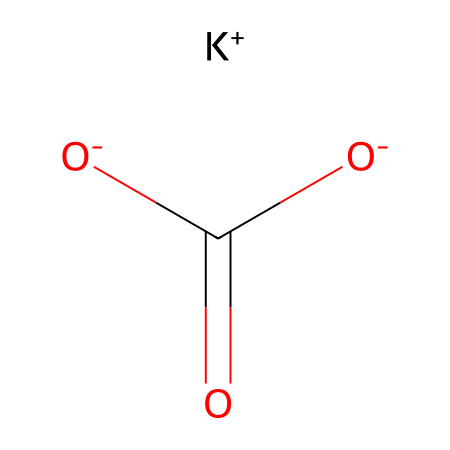What is the molecular formula of potassium bicarbonate? The SMILES representation breaks down to potassium (K), two oxygen atoms (O), and hydrogen (H) atoms in the bicarbonate ion (HCO3-). Therefore, the molecular formula is KHC(=O)2O2.
Answer: KHC(=O)2O2 How many oxygen atoms are in potassium bicarbonate? In the structure provided by the SMILES, there are three oxygen atoms indicated by the "[O-]" notation and the carbonyl "C(=O)", leading to a total of three.
Answer: 3 What is the charge of the potassium ion in this compound? The "[K+]" notation in the SMILES shows that the potassium ion has a positive charge, indicating it is a cation.
Answer: +1 What type of compound is potassium bicarbonate classified as? The chemical has a potassium cation and a bicarbonate anion, which lies within the category of salts, specifically electrolytes.
Answer: electrolyte Does potassium bicarbonate possess acidic properties? The presence of the bicarbonate anion (HCO3-) in the chemical structure gives potassium bicarbonate weakly acidic properties, as bicarbonate can donate hydrogen ions in solution.
Answer: yes What is the total number of hydrogen atoms in potassium bicarbonate? The SMILES displays one hydrogen in the HCO3- part and indicates there are two in total, counting the one from the bicarbonate and the hydrogen ion (H+), summing up to two hydrogen atoms.
Answer: 1 